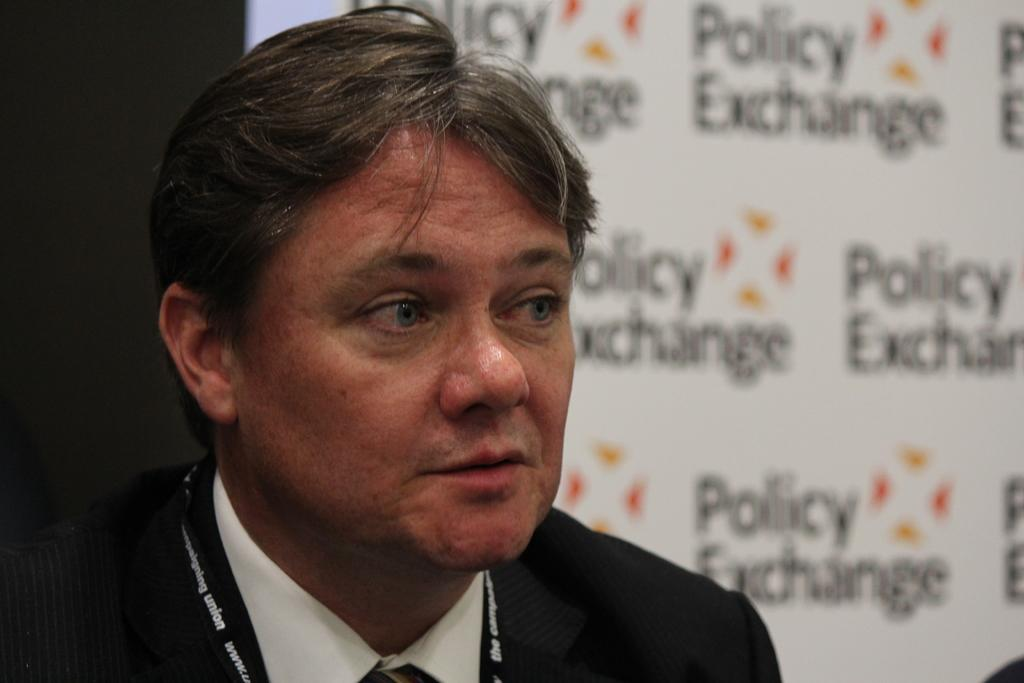What is the main subject in the center of the image? There is a person in the center of the image. What can be seen in the background of the image? There is an advertisement in the background of the image. How many babies are present in the image? There are no babies present in the image. What type of wood can be seen in the image? There is no wood present in the image. 